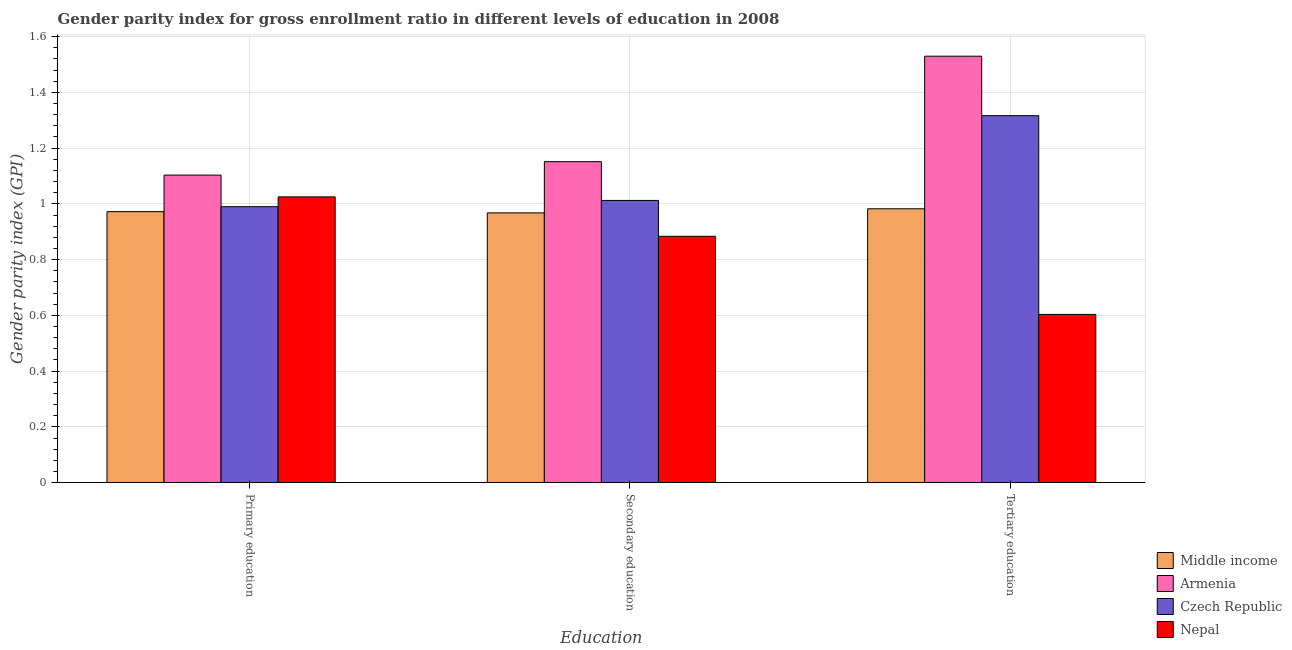How many groups of bars are there?
Give a very brief answer. 3. Are the number of bars per tick equal to the number of legend labels?
Provide a succinct answer. Yes. Are the number of bars on each tick of the X-axis equal?
Your answer should be compact. Yes. What is the label of the 2nd group of bars from the left?
Your response must be concise. Secondary education. What is the gender parity index in primary education in Czech Republic?
Provide a succinct answer. 0.99. Across all countries, what is the maximum gender parity index in primary education?
Provide a succinct answer. 1.1. Across all countries, what is the minimum gender parity index in secondary education?
Offer a very short reply. 0.88. In which country was the gender parity index in secondary education maximum?
Keep it short and to the point. Armenia. In which country was the gender parity index in tertiary education minimum?
Offer a very short reply. Nepal. What is the total gender parity index in tertiary education in the graph?
Provide a succinct answer. 4.43. What is the difference between the gender parity index in tertiary education in Nepal and that in Czech Republic?
Offer a terse response. -0.71. What is the difference between the gender parity index in tertiary education in Middle income and the gender parity index in primary education in Czech Republic?
Give a very brief answer. -0.01. What is the average gender parity index in tertiary education per country?
Your answer should be compact. 1.11. What is the difference between the gender parity index in tertiary education and gender parity index in secondary education in Armenia?
Offer a terse response. 0.38. In how many countries, is the gender parity index in primary education greater than 0.44 ?
Your answer should be very brief. 4. What is the ratio of the gender parity index in primary education in Middle income to that in Nepal?
Your answer should be compact. 0.95. Is the difference between the gender parity index in tertiary education in Armenia and Czech Republic greater than the difference between the gender parity index in secondary education in Armenia and Czech Republic?
Offer a terse response. Yes. What is the difference between the highest and the second highest gender parity index in tertiary education?
Give a very brief answer. 0.21. What is the difference between the highest and the lowest gender parity index in tertiary education?
Offer a very short reply. 0.93. Is the sum of the gender parity index in tertiary education in Armenia and Middle income greater than the maximum gender parity index in secondary education across all countries?
Provide a succinct answer. Yes. What does the 2nd bar from the left in Primary education represents?
Your answer should be compact. Armenia. What does the 4th bar from the right in Tertiary education represents?
Provide a short and direct response. Middle income. How many bars are there?
Provide a succinct answer. 12. How many countries are there in the graph?
Offer a terse response. 4. What is the difference between two consecutive major ticks on the Y-axis?
Provide a short and direct response. 0.2. Are the values on the major ticks of Y-axis written in scientific E-notation?
Provide a succinct answer. No. Does the graph contain any zero values?
Offer a terse response. No. Where does the legend appear in the graph?
Your response must be concise. Bottom right. What is the title of the graph?
Give a very brief answer. Gender parity index for gross enrollment ratio in different levels of education in 2008. Does "Croatia" appear as one of the legend labels in the graph?
Provide a short and direct response. No. What is the label or title of the X-axis?
Make the answer very short. Education. What is the label or title of the Y-axis?
Your answer should be very brief. Gender parity index (GPI). What is the Gender parity index (GPI) of Middle income in Primary education?
Your response must be concise. 0.97. What is the Gender parity index (GPI) of Armenia in Primary education?
Your answer should be very brief. 1.1. What is the Gender parity index (GPI) in Czech Republic in Primary education?
Offer a terse response. 0.99. What is the Gender parity index (GPI) of Nepal in Primary education?
Provide a short and direct response. 1.03. What is the Gender parity index (GPI) of Middle income in Secondary education?
Give a very brief answer. 0.97. What is the Gender parity index (GPI) in Armenia in Secondary education?
Provide a short and direct response. 1.15. What is the Gender parity index (GPI) of Czech Republic in Secondary education?
Your answer should be compact. 1.01. What is the Gender parity index (GPI) of Nepal in Secondary education?
Your response must be concise. 0.88. What is the Gender parity index (GPI) in Middle income in Tertiary education?
Your answer should be very brief. 0.98. What is the Gender parity index (GPI) in Armenia in Tertiary education?
Ensure brevity in your answer.  1.53. What is the Gender parity index (GPI) of Czech Republic in Tertiary education?
Your answer should be compact. 1.32. What is the Gender parity index (GPI) in Nepal in Tertiary education?
Give a very brief answer. 0.6. Across all Education, what is the maximum Gender parity index (GPI) of Middle income?
Your answer should be compact. 0.98. Across all Education, what is the maximum Gender parity index (GPI) in Armenia?
Ensure brevity in your answer.  1.53. Across all Education, what is the maximum Gender parity index (GPI) in Czech Republic?
Provide a short and direct response. 1.32. Across all Education, what is the maximum Gender parity index (GPI) in Nepal?
Give a very brief answer. 1.03. Across all Education, what is the minimum Gender parity index (GPI) in Middle income?
Keep it short and to the point. 0.97. Across all Education, what is the minimum Gender parity index (GPI) in Armenia?
Offer a terse response. 1.1. Across all Education, what is the minimum Gender parity index (GPI) in Czech Republic?
Your response must be concise. 0.99. Across all Education, what is the minimum Gender parity index (GPI) in Nepal?
Make the answer very short. 0.6. What is the total Gender parity index (GPI) of Middle income in the graph?
Your answer should be very brief. 2.92. What is the total Gender parity index (GPI) of Armenia in the graph?
Your response must be concise. 3.78. What is the total Gender parity index (GPI) in Czech Republic in the graph?
Make the answer very short. 3.32. What is the total Gender parity index (GPI) of Nepal in the graph?
Your answer should be compact. 2.51. What is the difference between the Gender parity index (GPI) of Middle income in Primary education and that in Secondary education?
Keep it short and to the point. 0. What is the difference between the Gender parity index (GPI) in Armenia in Primary education and that in Secondary education?
Your answer should be compact. -0.05. What is the difference between the Gender parity index (GPI) of Czech Republic in Primary education and that in Secondary education?
Give a very brief answer. -0.02. What is the difference between the Gender parity index (GPI) in Nepal in Primary education and that in Secondary education?
Give a very brief answer. 0.14. What is the difference between the Gender parity index (GPI) of Middle income in Primary education and that in Tertiary education?
Your answer should be compact. -0.01. What is the difference between the Gender parity index (GPI) in Armenia in Primary education and that in Tertiary education?
Offer a very short reply. -0.43. What is the difference between the Gender parity index (GPI) of Czech Republic in Primary education and that in Tertiary education?
Provide a succinct answer. -0.33. What is the difference between the Gender parity index (GPI) in Nepal in Primary education and that in Tertiary education?
Your response must be concise. 0.42. What is the difference between the Gender parity index (GPI) of Middle income in Secondary education and that in Tertiary education?
Provide a short and direct response. -0.01. What is the difference between the Gender parity index (GPI) in Armenia in Secondary education and that in Tertiary education?
Keep it short and to the point. -0.38. What is the difference between the Gender parity index (GPI) of Czech Republic in Secondary education and that in Tertiary education?
Offer a very short reply. -0.3. What is the difference between the Gender parity index (GPI) of Nepal in Secondary education and that in Tertiary education?
Keep it short and to the point. 0.28. What is the difference between the Gender parity index (GPI) in Middle income in Primary education and the Gender parity index (GPI) in Armenia in Secondary education?
Give a very brief answer. -0.18. What is the difference between the Gender parity index (GPI) in Middle income in Primary education and the Gender parity index (GPI) in Czech Republic in Secondary education?
Offer a very short reply. -0.04. What is the difference between the Gender parity index (GPI) of Middle income in Primary education and the Gender parity index (GPI) of Nepal in Secondary education?
Your answer should be very brief. 0.09. What is the difference between the Gender parity index (GPI) of Armenia in Primary education and the Gender parity index (GPI) of Czech Republic in Secondary education?
Keep it short and to the point. 0.09. What is the difference between the Gender parity index (GPI) of Armenia in Primary education and the Gender parity index (GPI) of Nepal in Secondary education?
Give a very brief answer. 0.22. What is the difference between the Gender parity index (GPI) of Czech Republic in Primary education and the Gender parity index (GPI) of Nepal in Secondary education?
Give a very brief answer. 0.11. What is the difference between the Gender parity index (GPI) of Middle income in Primary education and the Gender parity index (GPI) of Armenia in Tertiary education?
Your response must be concise. -0.56. What is the difference between the Gender parity index (GPI) in Middle income in Primary education and the Gender parity index (GPI) in Czech Republic in Tertiary education?
Provide a succinct answer. -0.34. What is the difference between the Gender parity index (GPI) in Middle income in Primary education and the Gender parity index (GPI) in Nepal in Tertiary education?
Your answer should be compact. 0.37. What is the difference between the Gender parity index (GPI) in Armenia in Primary education and the Gender parity index (GPI) in Czech Republic in Tertiary education?
Your response must be concise. -0.21. What is the difference between the Gender parity index (GPI) in Armenia in Primary education and the Gender parity index (GPI) in Nepal in Tertiary education?
Ensure brevity in your answer.  0.5. What is the difference between the Gender parity index (GPI) of Czech Republic in Primary education and the Gender parity index (GPI) of Nepal in Tertiary education?
Provide a short and direct response. 0.39. What is the difference between the Gender parity index (GPI) of Middle income in Secondary education and the Gender parity index (GPI) of Armenia in Tertiary education?
Your answer should be very brief. -0.56. What is the difference between the Gender parity index (GPI) in Middle income in Secondary education and the Gender parity index (GPI) in Czech Republic in Tertiary education?
Provide a succinct answer. -0.35. What is the difference between the Gender parity index (GPI) in Middle income in Secondary education and the Gender parity index (GPI) in Nepal in Tertiary education?
Make the answer very short. 0.36. What is the difference between the Gender parity index (GPI) in Armenia in Secondary education and the Gender parity index (GPI) in Czech Republic in Tertiary education?
Provide a succinct answer. -0.17. What is the difference between the Gender parity index (GPI) in Armenia in Secondary education and the Gender parity index (GPI) in Nepal in Tertiary education?
Offer a terse response. 0.55. What is the difference between the Gender parity index (GPI) in Czech Republic in Secondary education and the Gender parity index (GPI) in Nepal in Tertiary education?
Your response must be concise. 0.41. What is the average Gender parity index (GPI) of Middle income per Education?
Offer a terse response. 0.97. What is the average Gender parity index (GPI) in Armenia per Education?
Make the answer very short. 1.26. What is the average Gender parity index (GPI) in Czech Republic per Education?
Offer a very short reply. 1.11. What is the average Gender parity index (GPI) in Nepal per Education?
Provide a succinct answer. 0.84. What is the difference between the Gender parity index (GPI) in Middle income and Gender parity index (GPI) in Armenia in Primary education?
Keep it short and to the point. -0.13. What is the difference between the Gender parity index (GPI) in Middle income and Gender parity index (GPI) in Czech Republic in Primary education?
Give a very brief answer. -0.02. What is the difference between the Gender parity index (GPI) of Middle income and Gender parity index (GPI) of Nepal in Primary education?
Your answer should be compact. -0.05. What is the difference between the Gender parity index (GPI) of Armenia and Gender parity index (GPI) of Czech Republic in Primary education?
Ensure brevity in your answer.  0.11. What is the difference between the Gender parity index (GPI) in Armenia and Gender parity index (GPI) in Nepal in Primary education?
Make the answer very short. 0.08. What is the difference between the Gender parity index (GPI) of Czech Republic and Gender parity index (GPI) of Nepal in Primary education?
Your response must be concise. -0.04. What is the difference between the Gender parity index (GPI) in Middle income and Gender parity index (GPI) in Armenia in Secondary education?
Give a very brief answer. -0.18. What is the difference between the Gender parity index (GPI) in Middle income and Gender parity index (GPI) in Czech Republic in Secondary education?
Offer a very short reply. -0.04. What is the difference between the Gender parity index (GPI) of Middle income and Gender parity index (GPI) of Nepal in Secondary education?
Ensure brevity in your answer.  0.08. What is the difference between the Gender parity index (GPI) in Armenia and Gender parity index (GPI) in Czech Republic in Secondary education?
Provide a succinct answer. 0.14. What is the difference between the Gender parity index (GPI) of Armenia and Gender parity index (GPI) of Nepal in Secondary education?
Keep it short and to the point. 0.27. What is the difference between the Gender parity index (GPI) in Czech Republic and Gender parity index (GPI) in Nepal in Secondary education?
Provide a succinct answer. 0.13. What is the difference between the Gender parity index (GPI) of Middle income and Gender parity index (GPI) of Armenia in Tertiary education?
Your answer should be compact. -0.55. What is the difference between the Gender parity index (GPI) of Middle income and Gender parity index (GPI) of Czech Republic in Tertiary education?
Give a very brief answer. -0.33. What is the difference between the Gender parity index (GPI) of Middle income and Gender parity index (GPI) of Nepal in Tertiary education?
Your answer should be compact. 0.38. What is the difference between the Gender parity index (GPI) of Armenia and Gender parity index (GPI) of Czech Republic in Tertiary education?
Give a very brief answer. 0.21. What is the difference between the Gender parity index (GPI) in Armenia and Gender parity index (GPI) in Nepal in Tertiary education?
Your answer should be compact. 0.93. What is the difference between the Gender parity index (GPI) of Czech Republic and Gender parity index (GPI) of Nepal in Tertiary education?
Provide a short and direct response. 0.71. What is the ratio of the Gender parity index (GPI) of Armenia in Primary education to that in Secondary education?
Keep it short and to the point. 0.96. What is the ratio of the Gender parity index (GPI) in Czech Republic in Primary education to that in Secondary education?
Offer a very short reply. 0.98. What is the ratio of the Gender parity index (GPI) in Nepal in Primary education to that in Secondary education?
Your answer should be very brief. 1.16. What is the ratio of the Gender parity index (GPI) of Middle income in Primary education to that in Tertiary education?
Provide a short and direct response. 0.99. What is the ratio of the Gender parity index (GPI) in Armenia in Primary education to that in Tertiary education?
Offer a very short reply. 0.72. What is the ratio of the Gender parity index (GPI) in Czech Republic in Primary education to that in Tertiary education?
Your answer should be compact. 0.75. What is the ratio of the Gender parity index (GPI) in Nepal in Primary education to that in Tertiary education?
Your response must be concise. 1.7. What is the ratio of the Gender parity index (GPI) of Middle income in Secondary education to that in Tertiary education?
Provide a short and direct response. 0.99. What is the ratio of the Gender parity index (GPI) of Armenia in Secondary education to that in Tertiary education?
Provide a short and direct response. 0.75. What is the ratio of the Gender parity index (GPI) in Czech Republic in Secondary education to that in Tertiary education?
Give a very brief answer. 0.77. What is the ratio of the Gender parity index (GPI) of Nepal in Secondary education to that in Tertiary education?
Your answer should be very brief. 1.46. What is the difference between the highest and the second highest Gender parity index (GPI) of Middle income?
Offer a terse response. 0.01. What is the difference between the highest and the second highest Gender parity index (GPI) in Armenia?
Ensure brevity in your answer.  0.38. What is the difference between the highest and the second highest Gender parity index (GPI) of Czech Republic?
Keep it short and to the point. 0.3. What is the difference between the highest and the second highest Gender parity index (GPI) in Nepal?
Provide a short and direct response. 0.14. What is the difference between the highest and the lowest Gender parity index (GPI) in Middle income?
Your answer should be very brief. 0.01. What is the difference between the highest and the lowest Gender parity index (GPI) in Armenia?
Keep it short and to the point. 0.43. What is the difference between the highest and the lowest Gender parity index (GPI) in Czech Republic?
Provide a succinct answer. 0.33. What is the difference between the highest and the lowest Gender parity index (GPI) of Nepal?
Your answer should be compact. 0.42. 